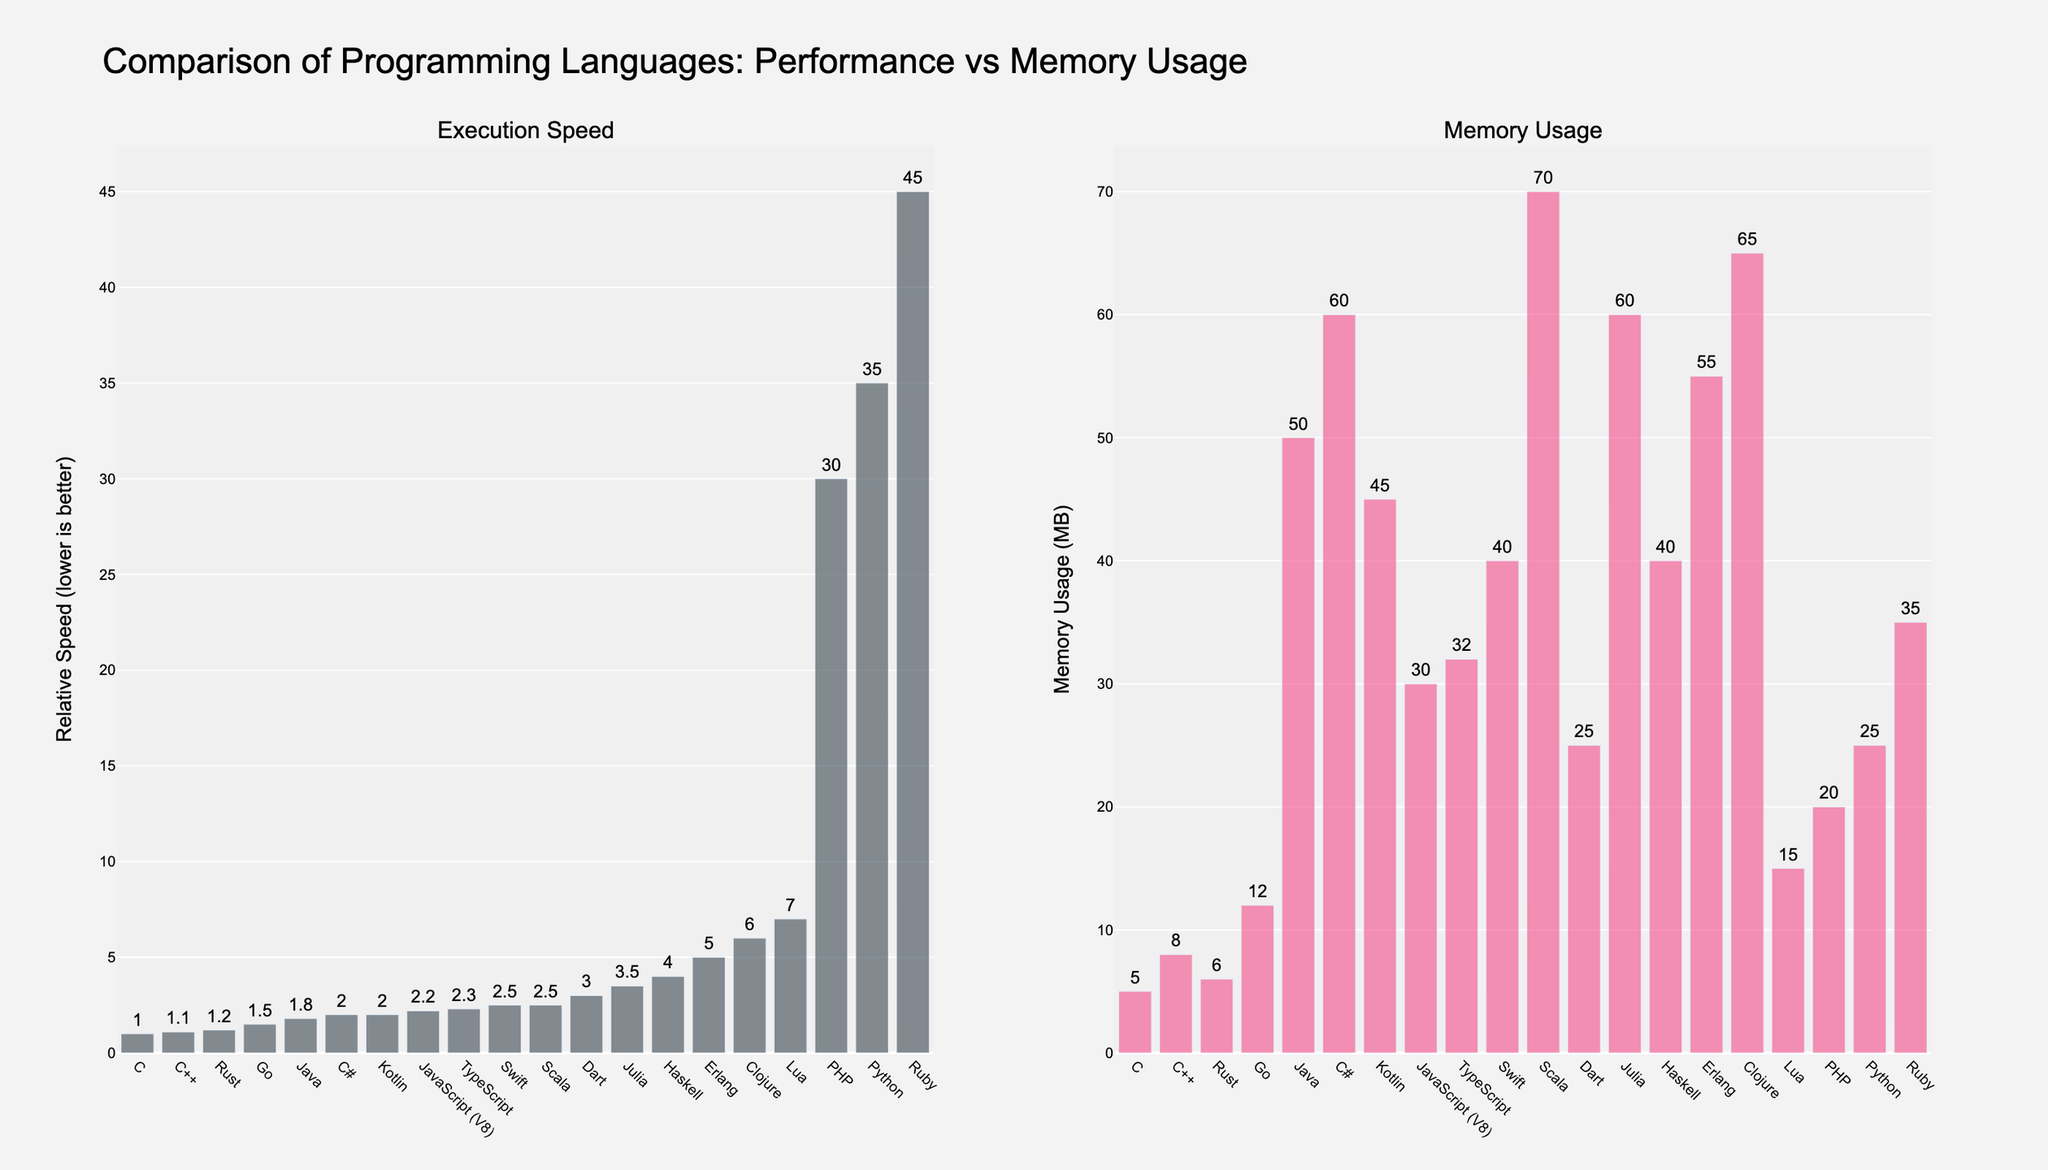What's the language with the highest execution speed? C has the lowest relative execution speed value of 1.0. Therefore, it is the fastest.
Answer: C Which language uses the most memory? The bar for Scala in the Memory Usage plot is the tallest, indicating that it uses the most memory at 70 MB.
Answer: Scala How does Python's execution speed compare to Ruby's? From the Execution Speed plot, Python has a relative execution speed of 35.0, while Ruby has 45.0. So, Python is faster.
Answer: Python is faster Which language consumes more memory: JavaScript (V8) or PHP? The Memory Usage plot shows that JavaScript (V8) uses 30 MB of memory, while PHP uses 20 MB. Therefore, JavaScript (V8) consumes more memory.
Answer: JavaScript (V8) What's the difference in memory usage between Go and Lua? From the Memory Usage plot, Go uses 12 MB, and Lua uses 15 MB. The difference is 15 MB - 12 MB = 3 MB.
Answer: 3 MB Which two languages have the closest execution speed? In the Execution Speed plot, Swift and Scala both have a relative speed of 2.5.
Answer: Swift and Scala On average, how much memory do Java and C# use? Java uses 50 MB and C# uses 60 MB. The average is (50 MB + 60 MB) / 2 = 55 MB.
Answer: 55 MB Which language has a higher execution speed: TypeScript or Dart? From the Execution Speed plot, TypeScript has a relative speed of 2.3, whereas Dart has 3.0. Thus, TypeScript has a higher execution speed (i.e., it is faster).
Answer: TypeScript is faster What is the total memory usage of Ruby, PHP, and Julia? Ruby uses 35 MB, PHP uses 20 MB, and Julia uses 60 MB. The total is 35 MB + 20 MB + 60 MB = 115 MB.
Answer: 115 MB 